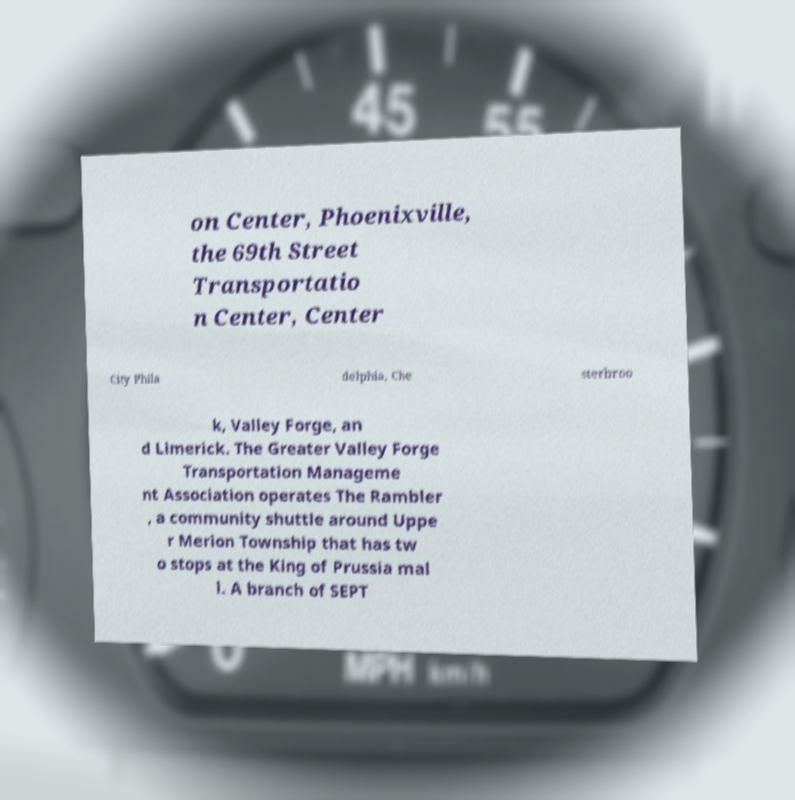I need the written content from this picture converted into text. Can you do that? on Center, Phoenixville, the 69th Street Transportatio n Center, Center City Phila delphia, Che sterbroo k, Valley Forge, an d Limerick. The Greater Valley Forge Transportation Manageme nt Association operates The Rambler , a community shuttle around Uppe r Merion Township that has tw o stops at the King of Prussia mal l. A branch of SEPT 